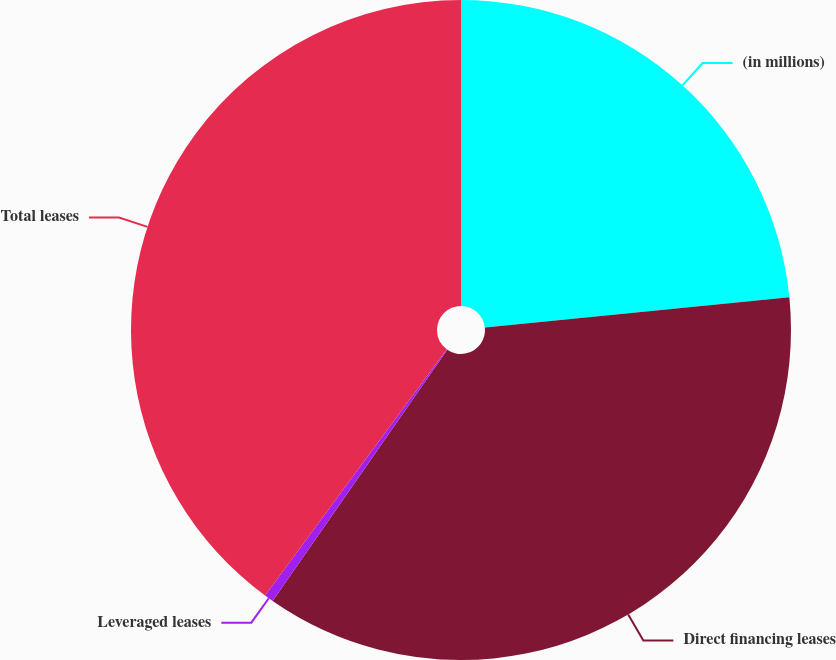Convert chart to OTSL. <chart><loc_0><loc_0><loc_500><loc_500><pie_chart><fcel>(in millions)<fcel>Direct financing leases<fcel>Leveraged leases<fcel>Total leases<nl><fcel>23.42%<fcel>36.25%<fcel>0.45%<fcel>39.88%<nl></chart> 